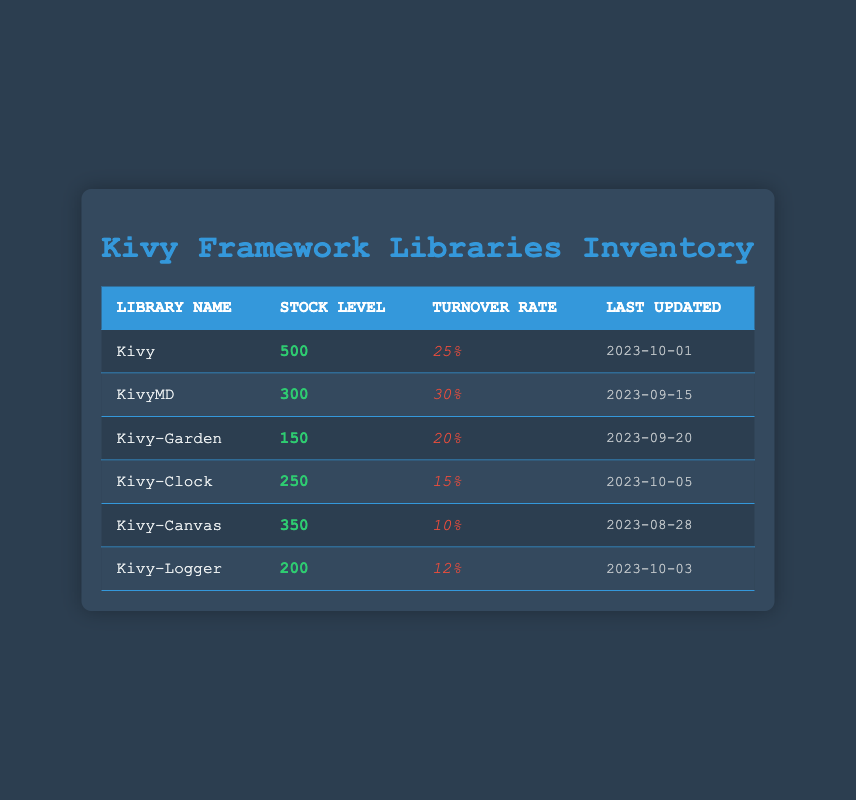What library has the highest stock level? The table displays stock levels for each library. Looking through the stock levels, Kivy has the highest stock level at 500.
Answer: Kivy What is the turnover rate of KivyMD? The turnover rate for KivyMD is listed in the table next to its stock level. It shows a turnover rate of 30%.
Answer: 30% How many libraries have a stock level below 250? By examining the stock levels, Kivy-Garden (150), Kivy-Clock (250), and Kivy-Logger (200) are below 250. That's three libraries.
Answer: 2 What is the average turnover rate of all libraries? To calculate the average, we sum the turnover rates: 0.25 + 0.30 + 0.20 + 0.15 + 0.10 + 0.12 = 1.12. There are 6 libraries, so the average turnover rate is 1.12 / 6 = 0.1867, rounded to two decimal places is 18.67%.
Answer: 18.67% Is the stock level for Kivy-Canvas greater than or equal to Kivy-Garden? Comparing the stock levels, Kivy-Canvas has 350 while Kivy-Garden has 150. Since 350 is greater than 150, the statement is true.
Answer: Yes Which library has the most recent last updated date? The last updated dates listed show that Kivy-Clock was last updated on 2023-10-05, making it the most recent update.
Answer: Kivy-Clock What is the difference in stock level between Kivy and Kivy-Logger? Kivy has a stock level of 500, while Kivy-Logger has a stock level of 200. The difference is 500 - 200 = 300.
Answer: 300 Does any library have a turnover rate higher than 25%? By checking the turnover rates, KivyMD (30%) is the only library that exceeds 25%.
Answer: Yes What percentage of libraries have a turnover rate less than 15%? There are 6 libraries in total: Kivy has 25%, KivyMD has 30%, Kivy-Garden has 20%, Kivy-Clock has 15%, Kivy-Canvas has 10%, and Kivy-Logger has 12%. Kivy-Canvas (10%) and Kivy-Logger (12%) have turnover rates less than 15%. That's 2 out of 6. Thus, (2/6)*100 = 33.33%.
Answer: 33.33% 